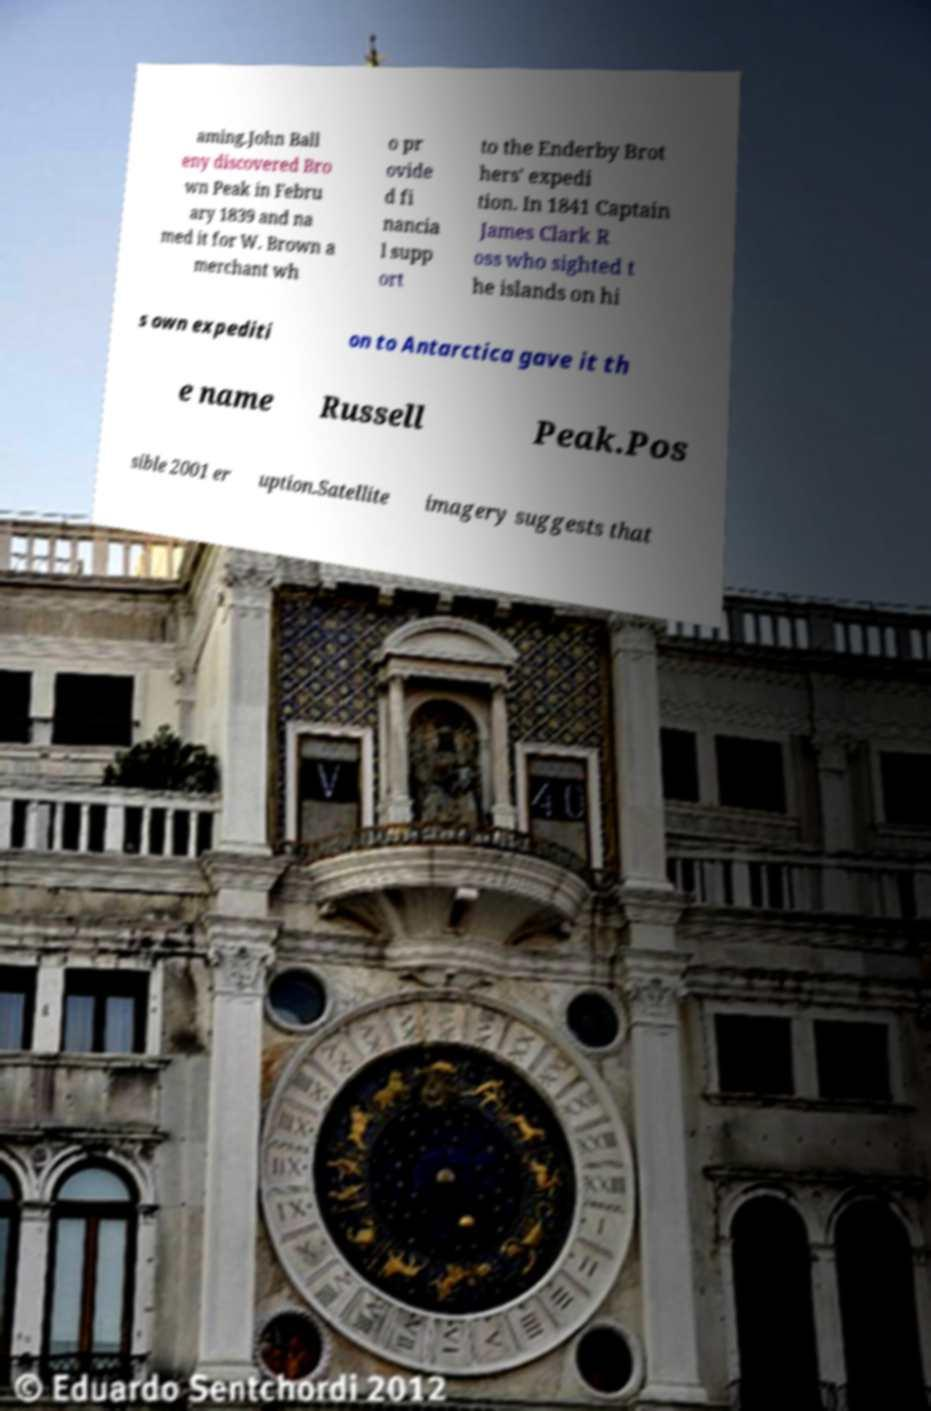Could you assist in decoding the text presented in this image and type it out clearly? aming.John Ball eny discovered Bro wn Peak in Febru ary 1839 and na med it for W. Brown a merchant wh o pr ovide d fi nancia l supp ort to the Enderby Brot hers' expedi tion. In 1841 Captain James Clark R oss who sighted t he islands on hi s own expediti on to Antarctica gave it th e name Russell Peak.Pos sible 2001 er uption.Satellite imagery suggests that 